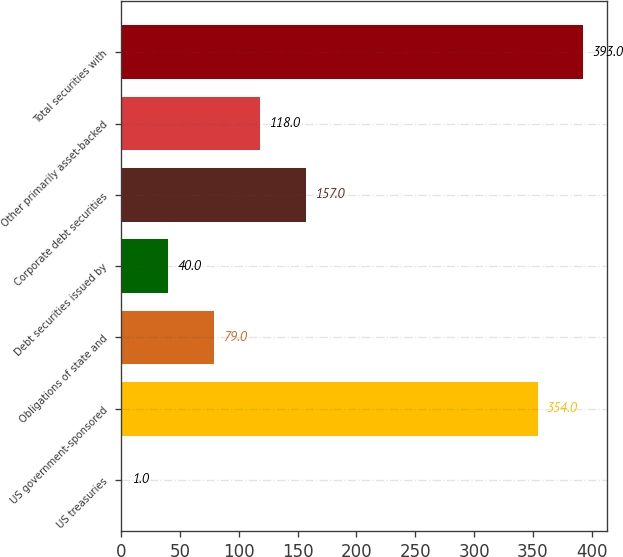Convert chart to OTSL. <chart><loc_0><loc_0><loc_500><loc_500><bar_chart><fcel>US treasuries<fcel>US government-sponsored<fcel>Obligations of state and<fcel>Debt securities issued by<fcel>Corporate debt securities<fcel>Other primarily asset-backed<fcel>Total securities with<nl><fcel>1<fcel>354<fcel>79<fcel>40<fcel>157<fcel>118<fcel>393<nl></chart> 